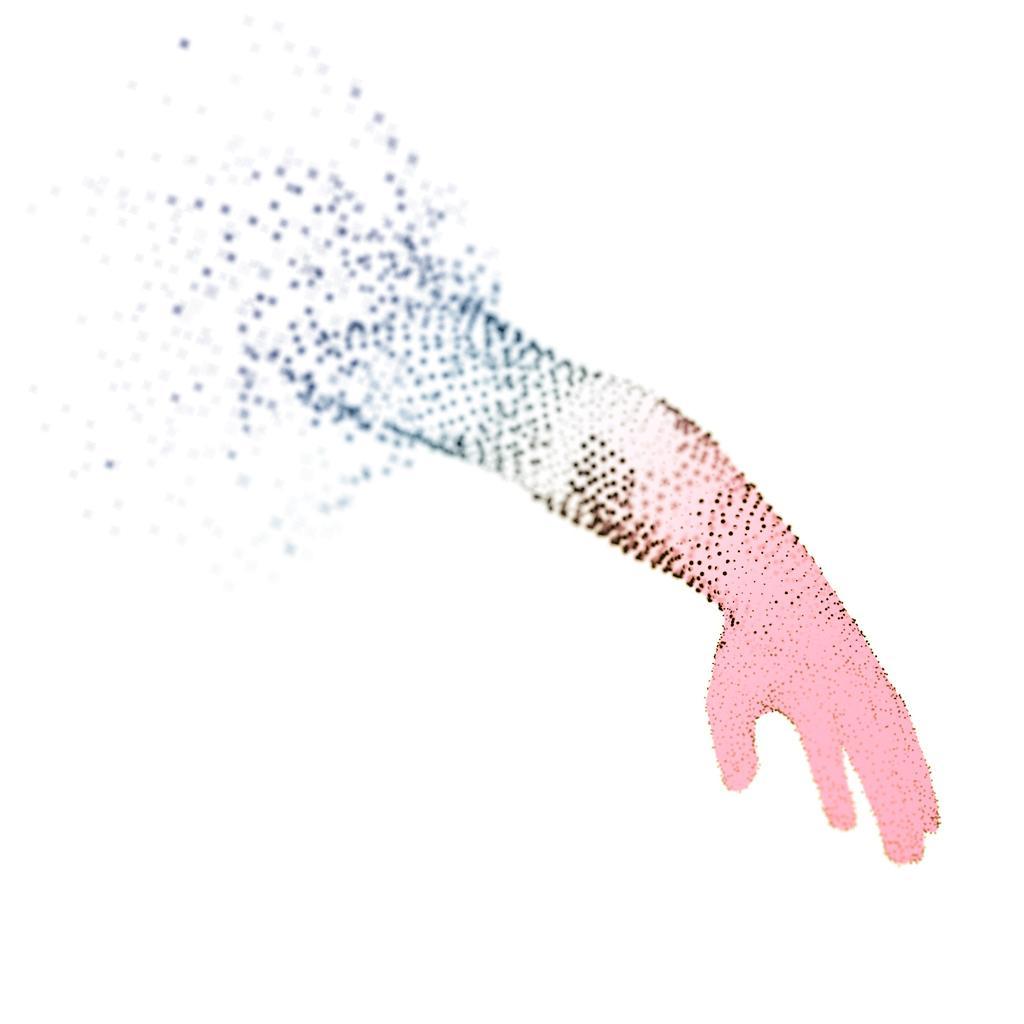Can you describe this image briefly? In this image I can see an art , in the art I can see person hand and background is white 